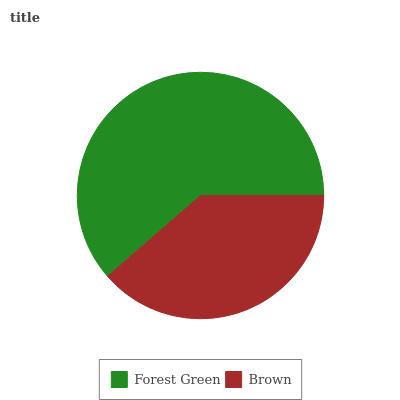Is Brown the minimum?
Answer yes or no. Yes. Is Forest Green the maximum?
Answer yes or no. Yes. Is Brown the maximum?
Answer yes or no. No. Is Forest Green greater than Brown?
Answer yes or no. Yes. Is Brown less than Forest Green?
Answer yes or no. Yes. Is Brown greater than Forest Green?
Answer yes or no. No. Is Forest Green less than Brown?
Answer yes or no. No. Is Forest Green the high median?
Answer yes or no. Yes. Is Brown the low median?
Answer yes or no. Yes. Is Brown the high median?
Answer yes or no. No. Is Forest Green the low median?
Answer yes or no. No. 